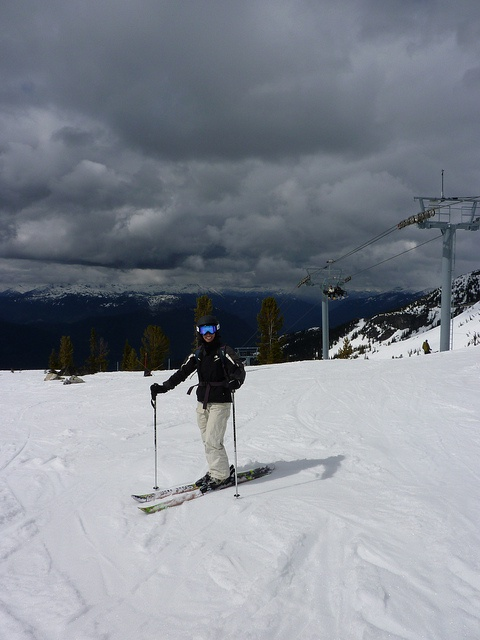Describe the objects in this image and their specific colors. I can see people in gray, black, and darkgray tones, skis in gray, darkgray, black, and lightgray tones, backpack in gray, black, lightgray, and darkgray tones, and people in gray, black, darkgreen, and lightgray tones in this image. 